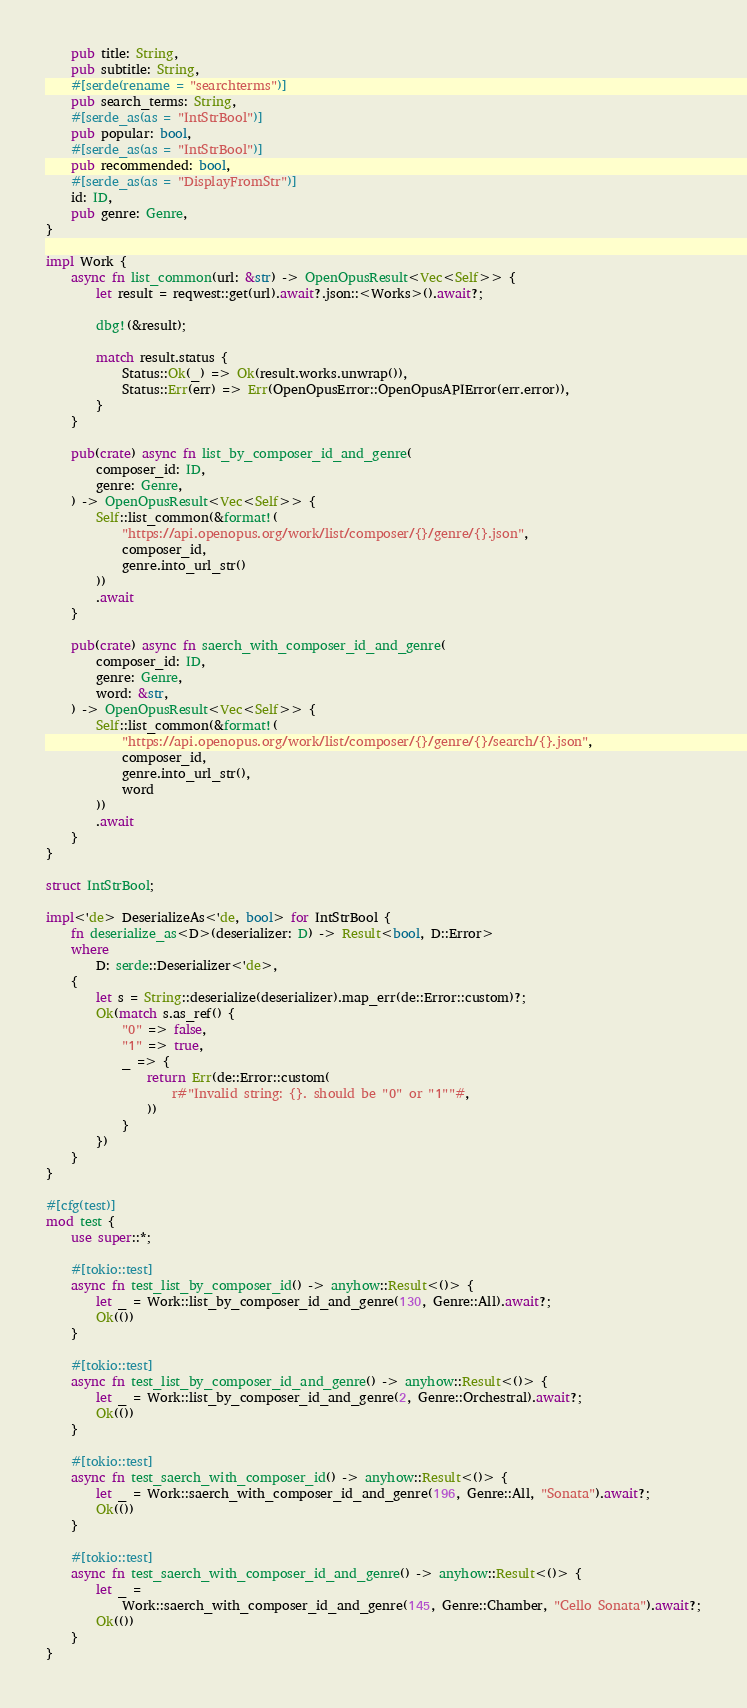Convert code to text. <code><loc_0><loc_0><loc_500><loc_500><_Rust_>    pub title: String,
    pub subtitle: String,
    #[serde(rename = "searchterms")]
    pub search_terms: String,
    #[serde_as(as = "IntStrBool")]
    pub popular: bool,
    #[serde_as(as = "IntStrBool")]
    pub recommended: bool,
    #[serde_as(as = "DisplayFromStr")]
    id: ID,
    pub genre: Genre,
}

impl Work {
    async fn list_common(url: &str) -> OpenOpusResult<Vec<Self>> {
        let result = reqwest::get(url).await?.json::<Works>().await?;

        dbg!(&result);

        match result.status {
            Status::Ok(_) => Ok(result.works.unwrap()),
            Status::Err(err) => Err(OpenOpusError::OpenOpusAPIError(err.error)),
        }
    }

    pub(crate) async fn list_by_composer_id_and_genre(
        composer_id: ID,
        genre: Genre,
    ) -> OpenOpusResult<Vec<Self>> {
        Self::list_common(&format!(
            "https://api.openopus.org/work/list/composer/{}/genre/{}.json",
            composer_id,
            genre.into_url_str()
        ))
        .await
    }

    pub(crate) async fn saerch_with_composer_id_and_genre(
        composer_id: ID,
        genre: Genre,
        word: &str,
    ) -> OpenOpusResult<Vec<Self>> {
        Self::list_common(&format!(
            "https://api.openopus.org/work/list/composer/{}/genre/{}/search/{}.json",
            composer_id,
            genre.into_url_str(),
            word
        ))
        .await
    }
}

struct IntStrBool;

impl<'de> DeserializeAs<'de, bool> for IntStrBool {
    fn deserialize_as<D>(deserializer: D) -> Result<bool, D::Error>
    where
        D: serde::Deserializer<'de>,
    {
        let s = String::deserialize(deserializer).map_err(de::Error::custom)?;
        Ok(match s.as_ref() {
            "0" => false,
            "1" => true,
            _ => {
                return Err(de::Error::custom(
                    r#"Invalid string: {}. should be "0" or "1""#,
                ))
            }
        })
    }
}

#[cfg(test)]
mod test {
    use super::*;

    #[tokio::test]
    async fn test_list_by_composer_id() -> anyhow::Result<()> {
        let _ = Work::list_by_composer_id_and_genre(130, Genre::All).await?;
        Ok(())
    }

    #[tokio::test]
    async fn test_list_by_composer_id_and_genre() -> anyhow::Result<()> {
        let _ = Work::list_by_composer_id_and_genre(2, Genre::Orchestral).await?;
        Ok(())
    }

    #[tokio::test]
    async fn test_saerch_with_composer_id() -> anyhow::Result<()> {
        let _ = Work::saerch_with_composer_id_and_genre(196, Genre::All, "Sonata").await?;
        Ok(())
    }

    #[tokio::test]
    async fn test_saerch_with_composer_id_and_genre() -> anyhow::Result<()> {
        let _ =
            Work::saerch_with_composer_id_and_genre(145, Genre::Chamber, "Cello Sonata").await?;
        Ok(())
    }
}
</code> 